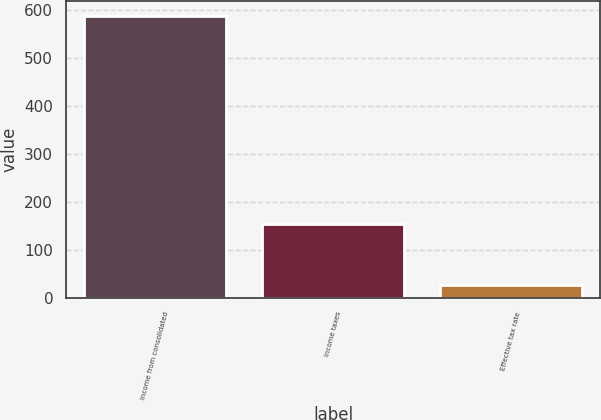Convert chart. <chart><loc_0><loc_0><loc_500><loc_500><bar_chart><fcel>Income from consolidated<fcel>Income taxes<fcel>Effective tax rate<nl><fcel>589.2<fcel>153<fcel>26<nl></chart> 